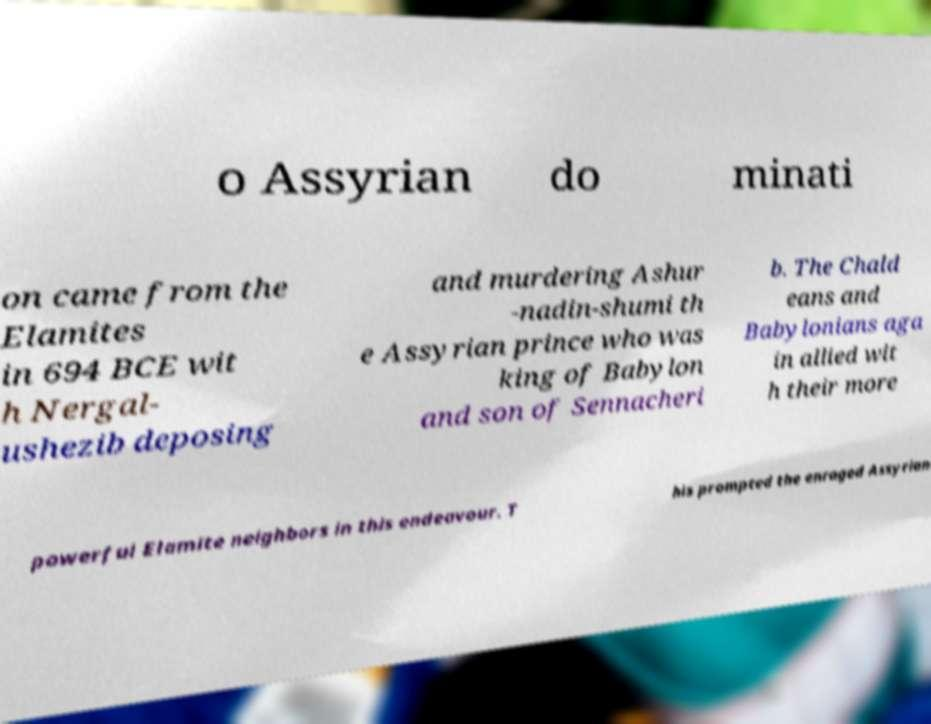Please identify and transcribe the text found in this image. o Assyrian do minati on came from the Elamites in 694 BCE wit h Nergal- ushezib deposing and murdering Ashur -nadin-shumi th e Assyrian prince who was king of Babylon and son of Sennacheri b. The Chald eans and Babylonians aga in allied wit h their more powerful Elamite neighbors in this endeavour. T his prompted the enraged Assyrian 